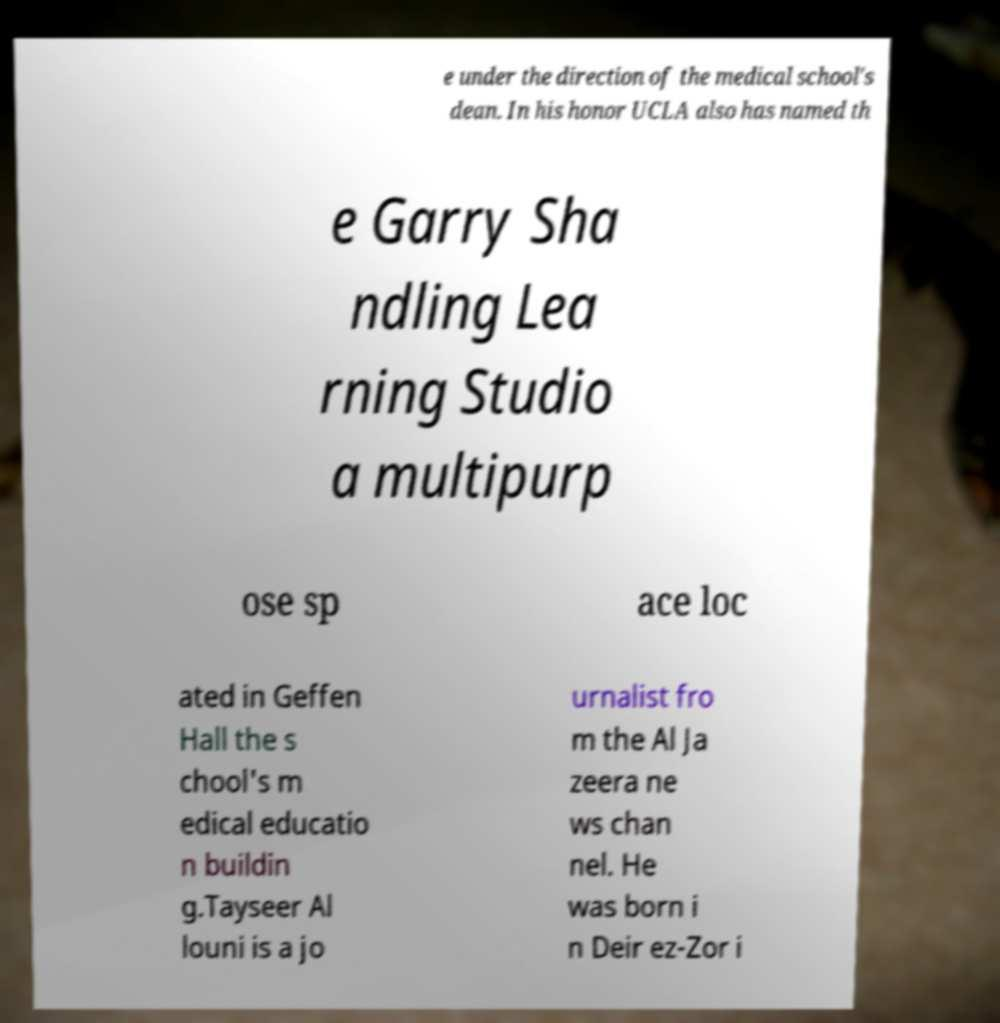For documentation purposes, I need the text within this image transcribed. Could you provide that? e under the direction of the medical school's dean. In his honor UCLA also has named th e Garry Sha ndling Lea rning Studio a multipurp ose sp ace loc ated in Geffen Hall the s chool's m edical educatio n buildin g.Tayseer Al louni is a jo urnalist fro m the Al Ja zeera ne ws chan nel. He was born i n Deir ez-Zor i 